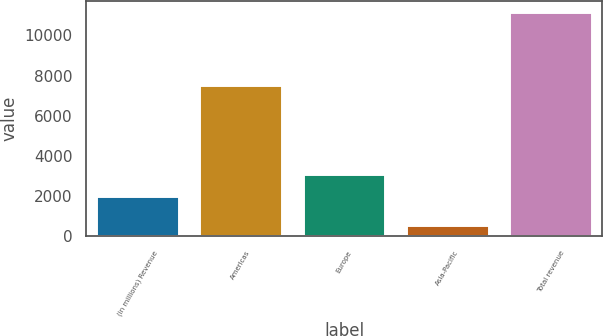Convert chart to OTSL. <chart><loc_0><loc_0><loc_500><loc_500><bar_chart><fcel>(in millions) Revenue<fcel>Americas<fcel>Europe<fcel>Asia-Pacific<fcel>Total revenue<nl><fcel>2016<fcel>7530<fcel>3083<fcel>542<fcel>11155<nl></chart> 